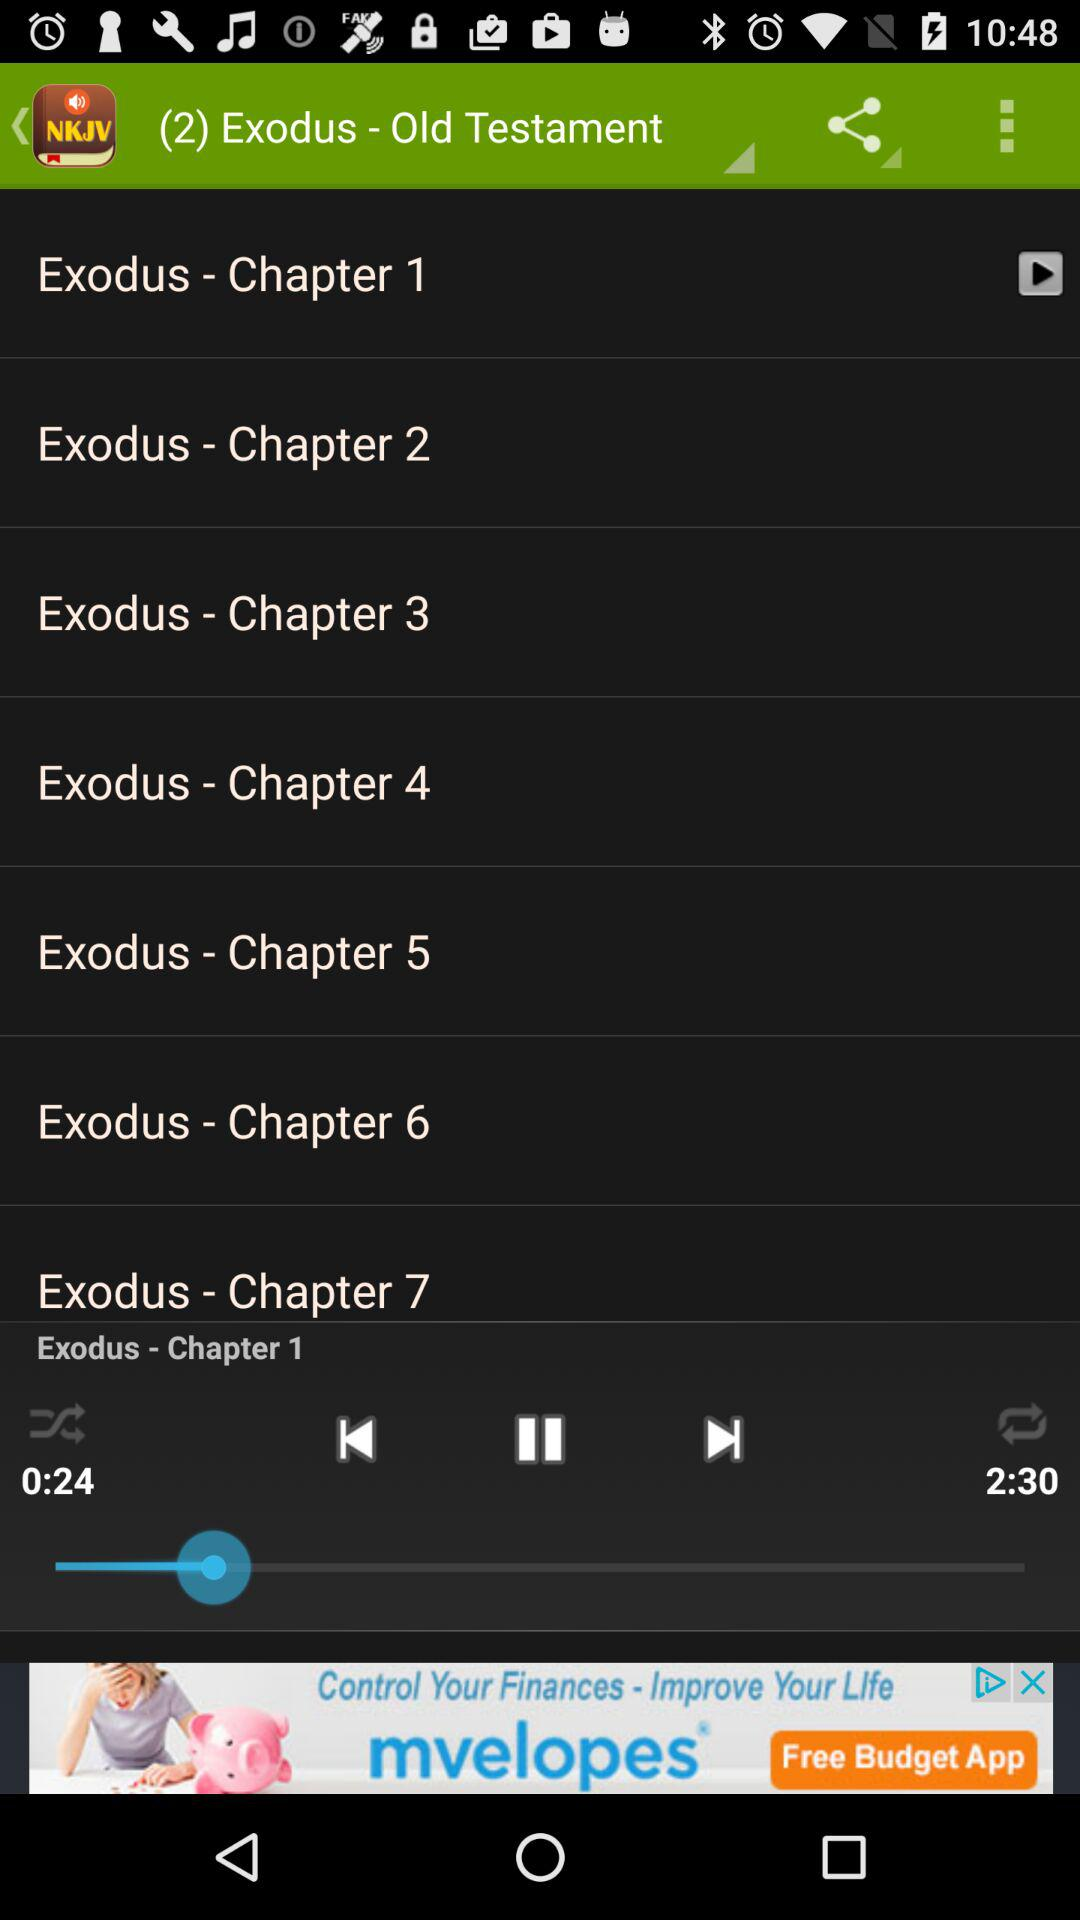What is the duration of Chapter 1? The duration of Chapter 1 is 2 minutes 30 seconds. 